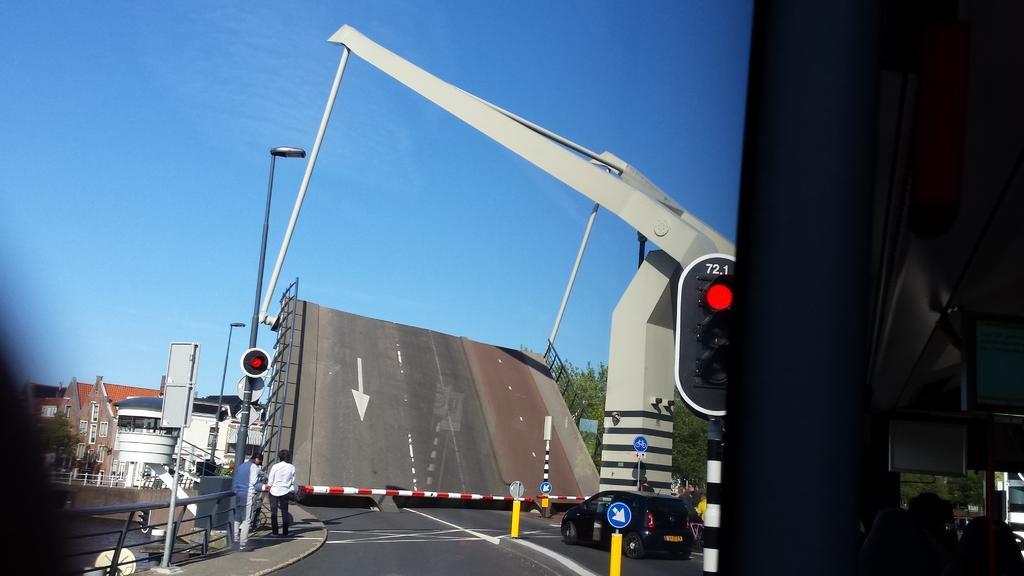In one or two sentences, can you explain what this image depicts? In this image we can see vehicles on the road. On the left there are people. On the right there is a traffic light. In the background there are poles, trees, buildings and sky. On the right there is a sign board. On the left there is a fence. 